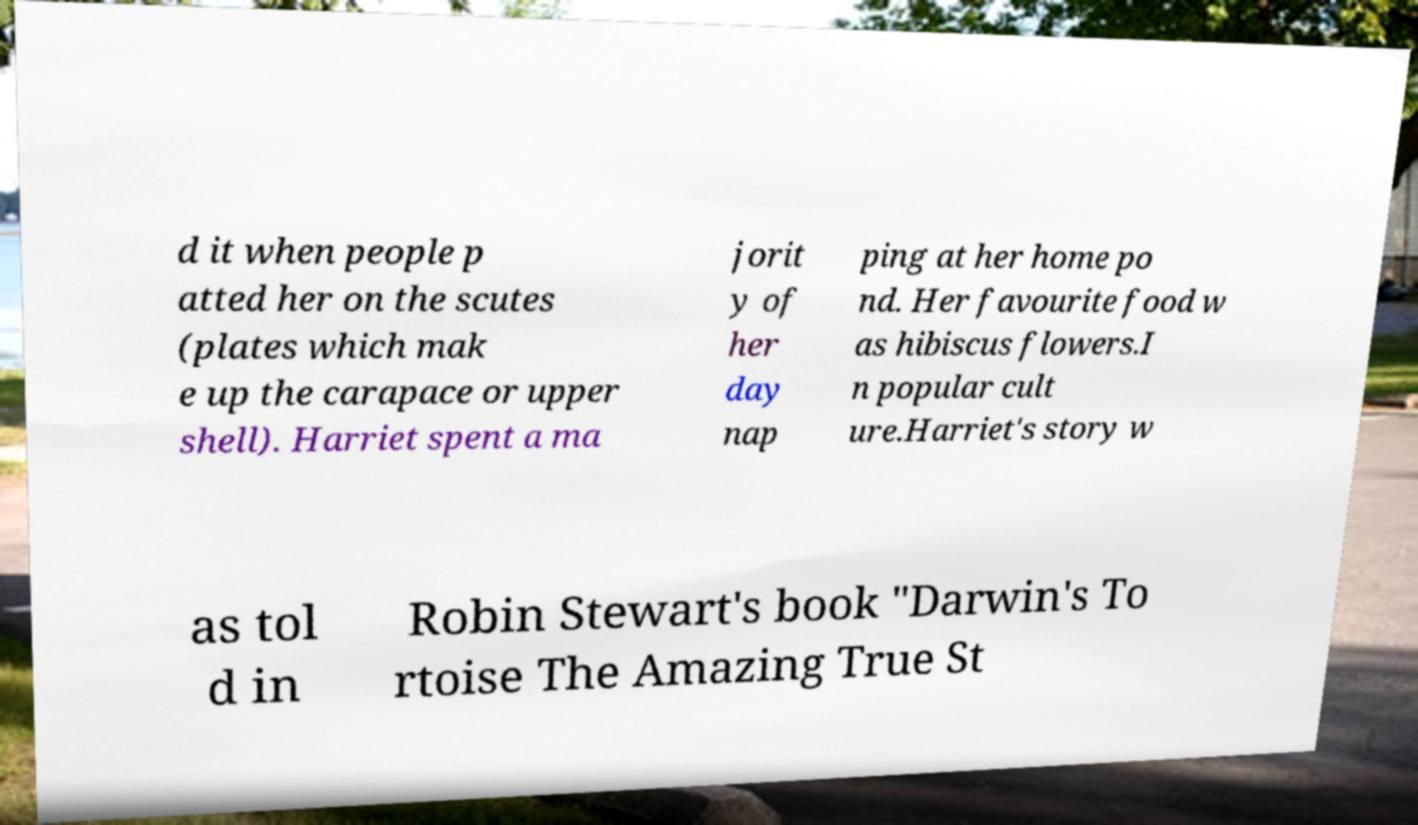Could you extract and type out the text from this image? d it when people p atted her on the scutes (plates which mak e up the carapace or upper shell). Harriet spent a ma jorit y of her day nap ping at her home po nd. Her favourite food w as hibiscus flowers.I n popular cult ure.Harriet's story w as tol d in Robin Stewart's book "Darwin's To rtoise The Amazing True St 